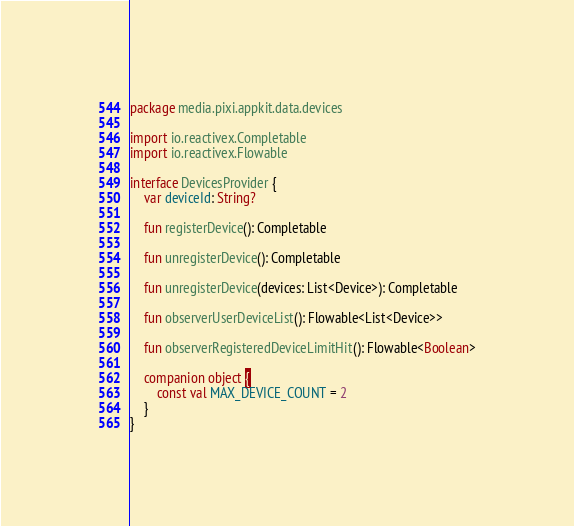<code> <loc_0><loc_0><loc_500><loc_500><_Kotlin_>package media.pixi.appkit.data.devices

import io.reactivex.Completable
import io.reactivex.Flowable

interface DevicesProvider {
    var deviceId: String?

    fun registerDevice(): Completable

    fun unregisterDevice(): Completable

    fun unregisterDevice(devices: List<Device>): Completable

    fun observerUserDeviceList(): Flowable<List<Device>>

    fun observerRegisteredDeviceLimitHit(): Flowable<Boolean>

    companion object {
        const val MAX_DEVICE_COUNT = 2
    }
}</code> 